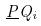Convert formula to latex. <formula><loc_0><loc_0><loc_500><loc_500>\underline { P } Q _ { i }</formula> 